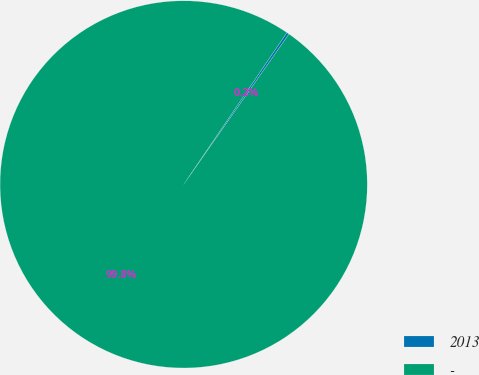Convert chart. <chart><loc_0><loc_0><loc_500><loc_500><pie_chart><fcel>2013<fcel>-<nl><fcel>0.22%<fcel>99.78%<nl></chart> 